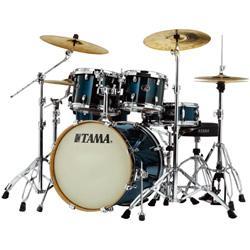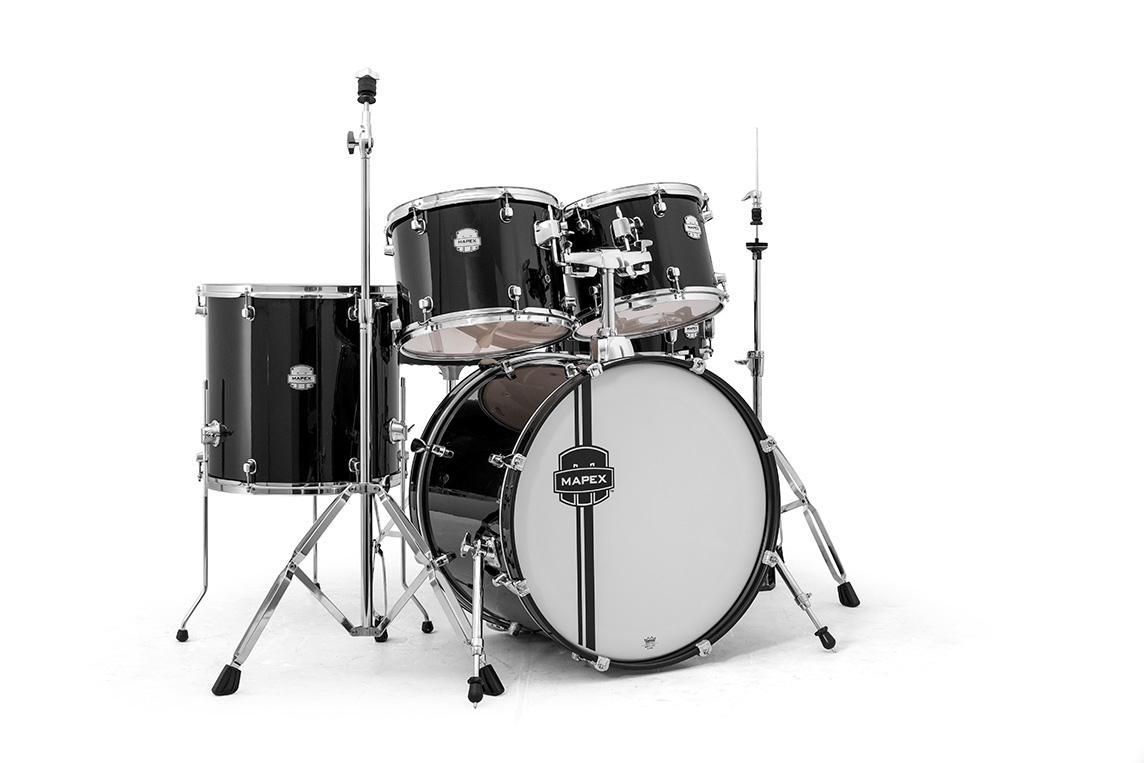The first image is the image on the left, the second image is the image on the right. Evaluate the accuracy of this statement regarding the images: "The drum kits on the left and right each have exactly one large central drum that stands with a side facing the front, and that exposed side has the same color in each image.". Is it true? Answer yes or no. Yes. 